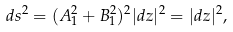Convert formula to latex. <formula><loc_0><loc_0><loc_500><loc_500>d s ^ { 2 } = ( A _ { 1 } ^ { 2 } + B _ { 1 } ^ { 2 } ) ^ { 2 } | d z | ^ { 2 } = | d z | ^ { 2 } ,</formula> 